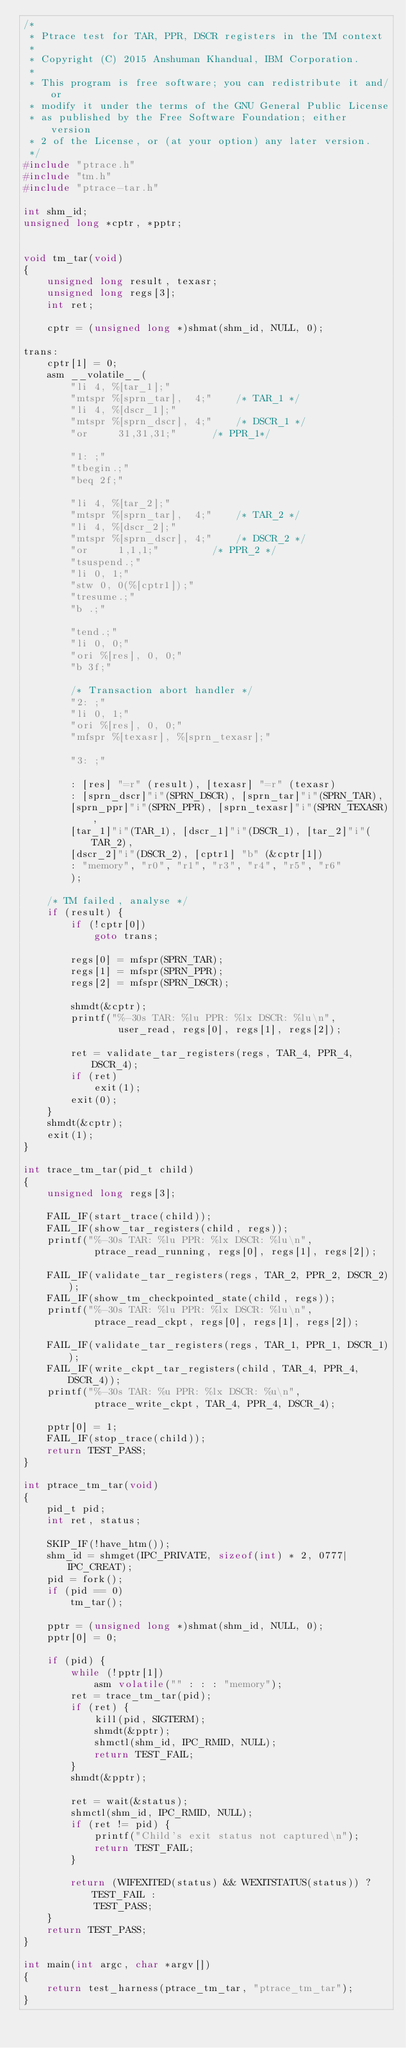<code> <loc_0><loc_0><loc_500><loc_500><_C_>/*
 * Ptrace test for TAR, PPR, DSCR registers in the TM context
 *
 * Copyright (C) 2015 Anshuman Khandual, IBM Corporation.
 *
 * This program is free software; you can redistribute it and/or
 * modify it under the terms of the GNU General Public License
 * as published by the Free Software Foundation; either version
 * 2 of the License, or (at your option) any later version.
 */
#include "ptrace.h"
#include "tm.h"
#include "ptrace-tar.h"

int shm_id;
unsigned long *cptr, *pptr;


void tm_tar(void)
{
	unsigned long result, texasr;
	unsigned long regs[3];
	int ret;

	cptr = (unsigned long *)shmat(shm_id, NULL, 0);

trans:
	cptr[1] = 0;
	asm __volatile__(
		"li	4, %[tar_1];"
		"mtspr %[sprn_tar],  4;"	/* TAR_1 */
		"li	4, %[dscr_1];"
		"mtspr %[sprn_dscr], 4;"	/* DSCR_1 */
		"or     31,31,31;"		/* PPR_1*/

		"1: ;"
		"tbegin.;"
		"beq 2f;"

		"li	4, %[tar_2];"
		"mtspr %[sprn_tar],  4;"	/* TAR_2 */
		"li	4, %[dscr_2];"
		"mtspr %[sprn_dscr], 4;"	/* DSCR_2 */
		"or     1,1,1;"			/* PPR_2 */
		"tsuspend.;"
		"li 0, 1;"
		"stw 0, 0(%[cptr1]);"
		"tresume.;"
		"b .;"

		"tend.;"
		"li 0, 0;"
		"ori %[res], 0, 0;"
		"b 3f;"

		/* Transaction abort handler */
		"2: ;"
		"li 0, 1;"
		"ori %[res], 0, 0;"
		"mfspr %[texasr], %[sprn_texasr];"

		"3: ;"

		: [res] "=r" (result), [texasr] "=r" (texasr)
		: [sprn_dscr]"i"(SPRN_DSCR), [sprn_tar]"i"(SPRN_TAR),
		[sprn_ppr]"i"(SPRN_PPR), [sprn_texasr]"i"(SPRN_TEXASR),
		[tar_1]"i"(TAR_1), [dscr_1]"i"(DSCR_1), [tar_2]"i"(TAR_2),
		[dscr_2]"i"(DSCR_2), [cptr1] "b" (&cptr[1])
		: "memory", "r0", "r1", "r3", "r4", "r5", "r6"
		);

	/* TM failed, analyse */
	if (result) {
		if (!cptr[0])
			goto trans;

		regs[0] = mfspr(SPRN_TAR);
		regs[1] = mfspr(SPRN_PPR);
		regs[2] = mfspr(SPRN_DSCR);

		shmdt(&cptr);
		printf("%-30s TAR: %lu PPR: %lx DSCR: %lu\n",
				user_read, regs[0], regs[1], regs[2]);

		ret = validate_tar_registers(regs, TAR_4, PPR_4, DSCR_4);
		if (ret)
			exit(1);
		exit(0);
	}
	shmdt(&cptr);
	exit(1);
}

int trace_tm_tar(pid_t child)
{
	unsigned long regs[3];

	FAIL_IF(start_trace(child));
	FAIL_IF(show_tar_registers(child, regs));
	printf("%-30s TAR: %lu PPR: %lx DSCR: %lu\n",
			ptrace_read_running, regs[0], regs[1], regs[2]);

	FAIL_IF(validate_tar_registers(regs, TAR_2, PPR_2, DSCR_2));
	FAIL_IF(show_tm_checkpointed_state(child, regs));
	printf("%-30s TAR: %lu PPR: %lx DSCR: %lu\n",
			ptrace_read_ckpt, regs[0], regs[1], regs[2]);

	FAIL_IF(validate_tar_registers(regs, TAR_1, PPR_1, DSCR_1));
	FAIL_IF(write_ckpt_tar_registers(child, TAR_4, PPR_4, DSCR_4));
	printf("%-30s TAR: %u PPR: %lx DSCR: %u\n",
			ptrace_write_ckpt, TAR_4, PPR_4, DSCR_4);

	pptr[0] = 1;
	FAIL_IF(stop_trace(child));
	return TEST_PASS;
}

int ptrace_tm_tar(void)
{
	pid_t pid;
	int ret, status;

	SKIP_IF(!have_htm());
	shm_id = shmget(IPC_PRIVATE, sizeof(int) * 2, 0777|IPC_CREAT);
	pid = fork();
	if (pid == 0)
		tm_tar();

	pptr = (unsigned long *)shmat(shm_id, NULL, 0);
	pptr[0] = 0;

	if (pid) {
		while (!pptr[1])
			asm volatile("" : : : "memory");
		ret = trace_tm_tar(pid);
		if (ret) {
			kill(pid, SIGTERM);
			shmdt(&pptr);
			shmctl(shm_id, IPC_RMID, NULL);
			return TEST_FAIL;
		}
		shmdt(&pptr);

		ret = wait(&status);
		shmctl(shm_id, IPC_RMID, NULL);
		if (ret != pid) {
			printf("Child's exit status not captured\n");
			return TEST_FAIL;
		}

		return (WIFEXITED(status) && WEXITSTATUS(status)) ? TEST_FAIL :
			TEST_PASS;
	}
	return TEST_PASS;
}

int main(int argc, char *argv[])
{
	return test_harness(ptrace_tm_tar, "ptrace_tm_tar");
}
</code> 